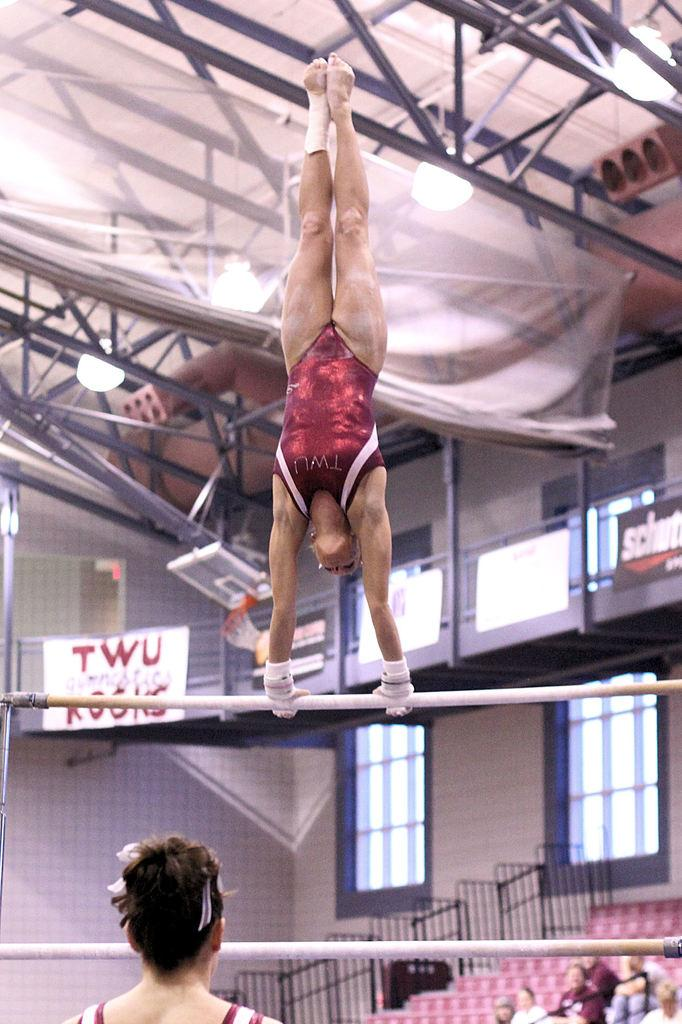<image>
Summarize the visual content of the image. a person on a pole with twu in the background 